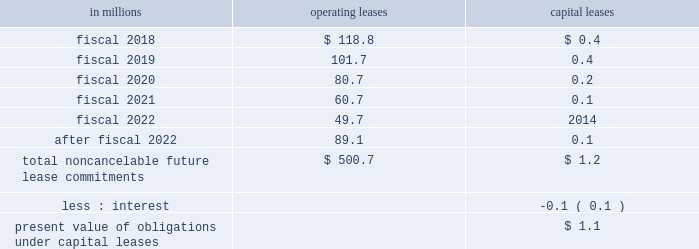Able to reasonably estimate the timing of future cash flows beyond 12 months due to uncertainties in the timing of tax audit outcomes .
The remaining amount of our unrecognized tax liability was classified in other liabilities .
We report accrued interest and penalties related to unrecognized tax benefit liabilities in income tax expense .
For fiscal 2017 , we recognized a net benefit of $ 5.6 million of tax-related net interest and penalties , and had $ 23.1 million of accrued interest and penalties as of may 28 , 2017 .
For fiscal 2016 , we recognized a net benefit of $ 2.7 million of tax-related net interest and penalties , and had $ 32.1 million of accrued interest and penalties as of may 29 , 2016 .
Note 15 .
Leases , other commitments , and contingencies the company 2019s leases are generally for warehouse space and equipment .
Rent expense under all operating leases from continuing operations was $ 188.1 million in fiscal 2017 , $ 189.1 million in fiscal 2016 , and $ 193.5 million in fiscal 2015 .
Some operating leases require payment of property taxes , insurance , and maintenance costs in addition to the rent payments .
Contingent and escalation rent in excess of minimum rent payments and sublease income netted in rent expense were insignificant .
Noncancelable future lease commitments are : operating capital in millions leases leases .
Depreciation on capital leases is recorded as deprecia- tion expense in our results of operations .
As of may 28 , 2017 , we have issued guarantees and comfort letters of $ 504.7 million for the debt and other obligations of consolidated subsidiaries , and guarantees and comfort letters of $ 165.3 million for the debt and other obligations of non-consolidated affiliates , mainly cpw .
In addition , off-balance sheet arrangements are generally limited to the future payments under non-cancelable operating leases , which totaled $ 500.7 million as of may 28 , 2017 .
Note 16 .
Business segment and geographic information we operate in the consumer foods industry .
In the third quarter of fiscal 2017 , we announced a new global orga- nization structure to streamline our leadership , enhance global scale , and drive improved operational agility to maximize our growth capabilities .
As a result of this global reorganization , beginning in the third quarter of fiscal 2017 , we reported results for our four operating segments as follows : north america retail , 65.3 percent of our fiscal 2017 consolidated net sales ; convenience stores & foodservice , 12.0 percent of our fiscal 2017 consolidated net sales ; europe & australia , 11.7 percent of our fiscal 2017 consolidated net sales ; and asia & latin america , 11.0 percent of our fiscal 2017 consoli- dated net sales .
We have restated our net sales by seg- ment and segment operating profit amounts to reflect our new operating segments .
These segment changes had no effect on previously reported consolidated net sales , operating profit , net earnings attributable to general mills , or earnings per share .
Our north america retail operating segment consists of our former u.s .
Retail operating units and our canada region .
Within our north america retail operating seg- ment , our former u.s .
Meals operating unit and u.s .
Baking operating unit have been combined into one operating unit : u.s .
Meals & baking .
Our convenience stores & foodservice operating segment is unchanged .
Our europe & australia operating segment consists of our former europe region .
Our asia & latin america operating segment consists of our former asia/pacific and latin america regions .
Under our new organization structure , our chief operating decision maker assesses performance and makes decisions about resources to be allocated to our segments at the north america retail , convenience stores & foodservice , europe & australia , and asia & latin america operating segment level .
Our north america retail operating segment reflects business with a wide variety of grocery stores , mass merchandisers , membership stores , natural food chains , drug , dollar and discount chains , and e-commerce gro- cery providers .
Our product categories in this business 84 general mills .
What is the change in balance of accrued interest and penalties from 2016 to 2017? 
Computations: (23.1 - 32.1)
Answer: -9.0. 